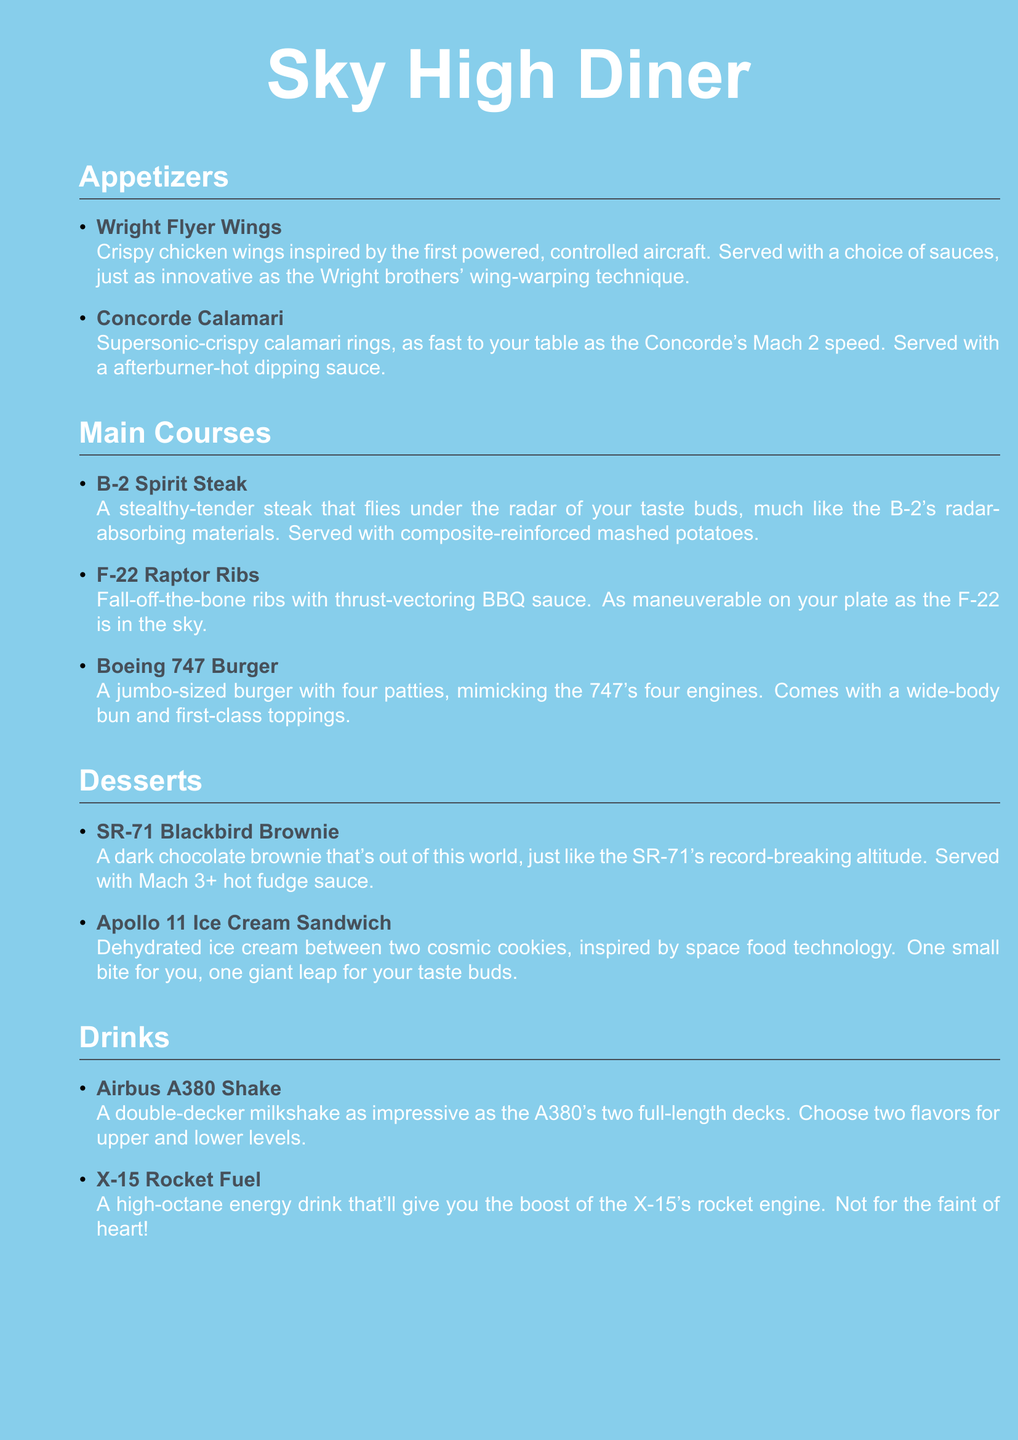What is the name of the appetizer that features chicken wings? The menu lists a dish called "Wright Flyer Wings," which features crispy chicken wings.
Answer: Wright Flyer Wings How is the Concorde Calamari described? The Concorde Calamari is described as "supersonic-crispy calamari rings" served with a hot dipping sauce.
Answer: Supersonic-crispy calamari rings What type of steak is served as a main course? The main course includes a steak called the "B-2 Spirit Steak," which is described as tender and stealthy.
Answer: B-2 Spirit Steak Which dessert is inspired by space food technology? The dessert inspired by space food technology is the "Apollo 11 Ice Cream Sandwich," which features dehydrated ice cream.
Answer: Apollo 11 Ice Cream Sandwich What is special about the Boeing 747 Burger? The Boeing 747 Burger is designed to mimic the 747's four engines, comprising four patties.
Answer: Four patties How many flavors can be chosen for the Airbus A380 Shake? The Airbus A380 Shake allows customers to choose two flavors, one for each deck.
Answer: Two flavors What ingredient gives the X-15 Rocket Fuel its high-octane reputation? The X-15 Rocket Fuel is an energy drink described as having a high-octane quality, which relates to the performance of the X-15's rocket engine.
Answer: High-octane energy drink Which dish features thrust-vectoring BBQ sauce? The "F-22 Raptor Ribs" feature thrust-vectoring BBQ sauce, enhancing their flavor profile.
Answer: F-22 Raptor Ribs What is the flavor profile of the SR-71 Blackbird Brownie? The SR-71 Blackbird Brownie is a dark chocolate brownie served with hot fudge sauce.
Answer: Dark chocolate brownie 